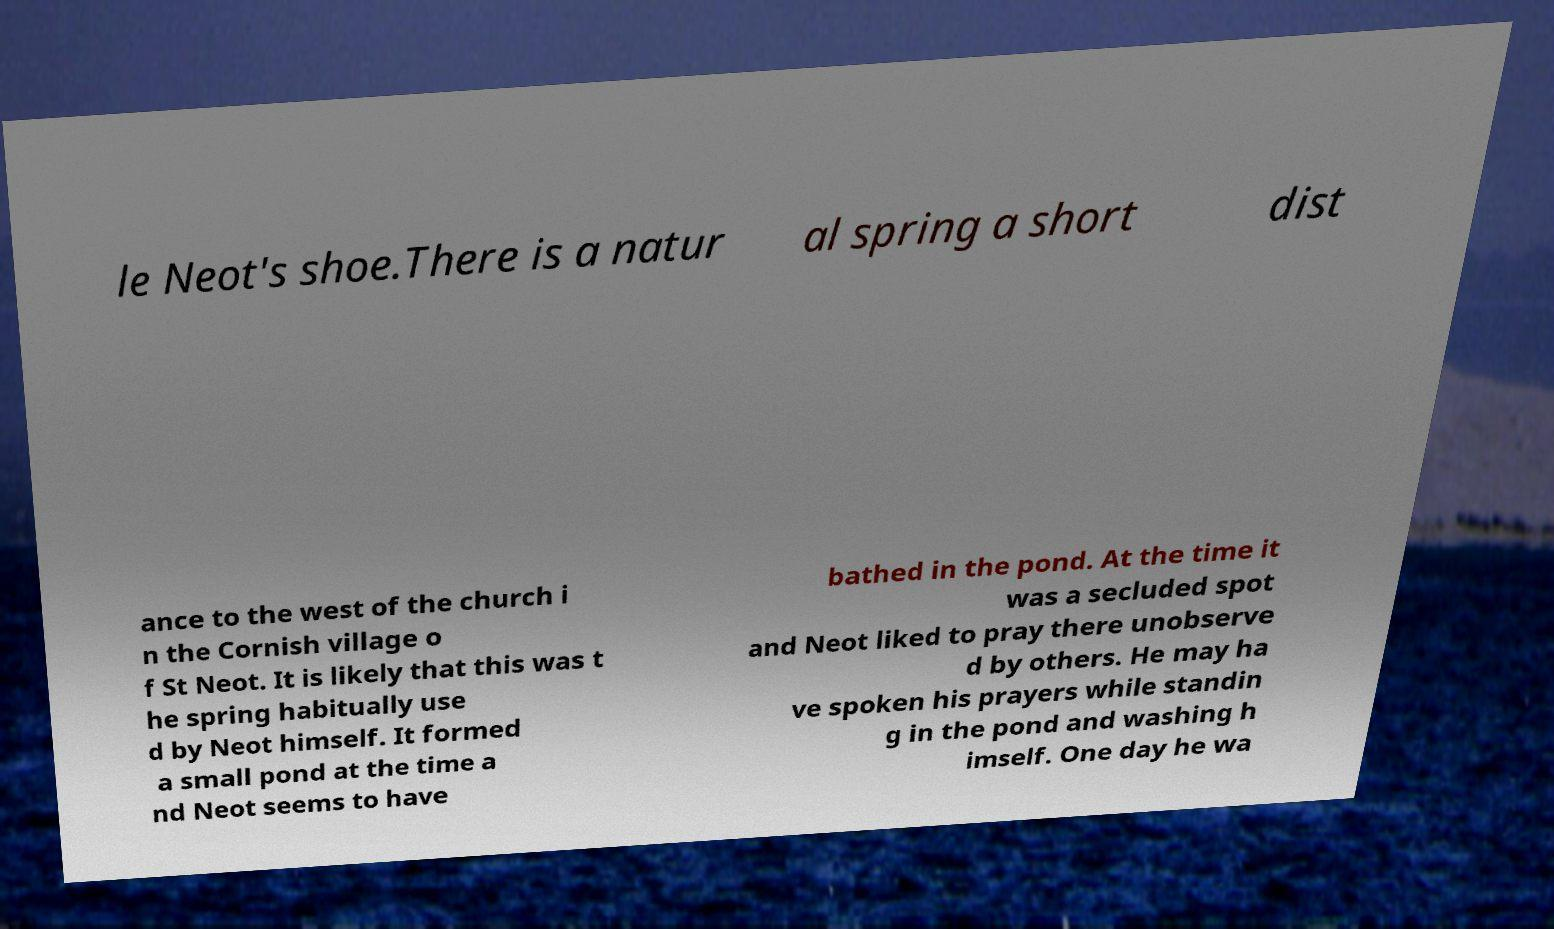I need the written content from this picture converted into text. Can you do that? le Neot's shoe.There is a natur al spring a short dist ance to the west of the church i n the Cornish village o f St Neot. It is likely that this was t he spring habitually use d by Neot himself. It formed a small pond at the time a nd Neot seems to have bathed in the pond. At the time it was a secluded spot and Neot liked to pray there unobserve d by others. He may ha ve spoken his prayers while standin g in the pond and washing h imself. One day he wa 